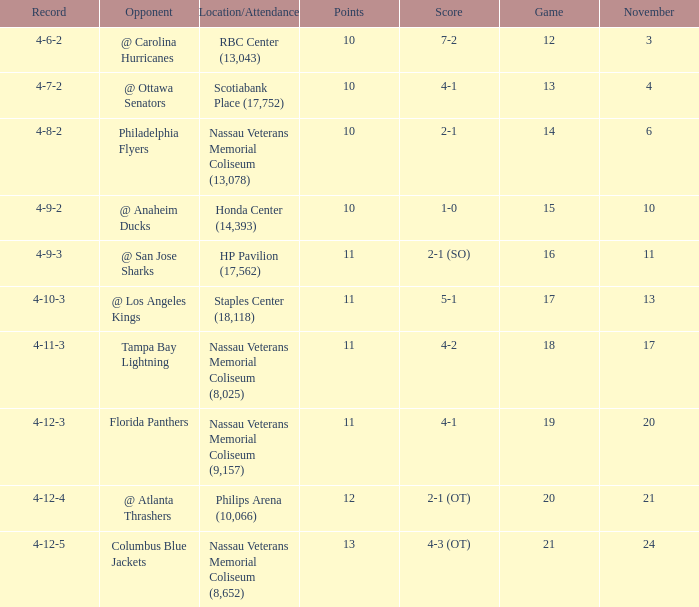What is every record for game 13? 4-7-2. 